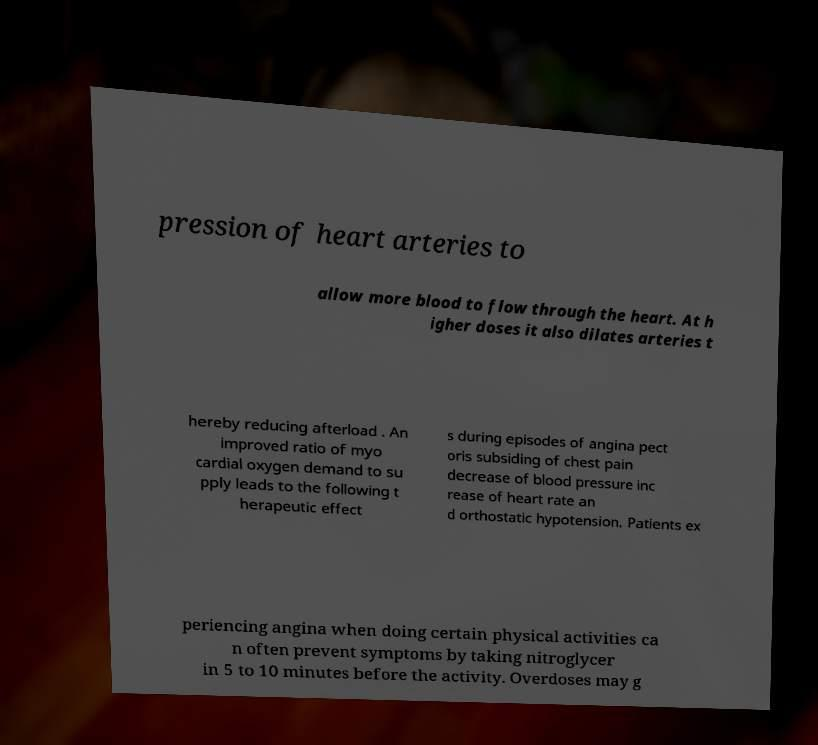Could you extract and type out the text from this image? pression of heart arteries to allow more blood to flow through the heart. At h igher doses it also dilates arteries t hereby reducing afterload . An improved ratio of myo cardial oxygen demand to su pply leads to the following t herapeutic effect s during episodes of angina pect oris subsiding of chest pain decrease of blood pressure inc rease of heart rate an d orthostatic hypotension. Patients ex periencing angina when doing certain physical activities ca n often prevent symptoms by taking nitroglycer in 5 to 10 minutes before the activity. Overdoses may g 